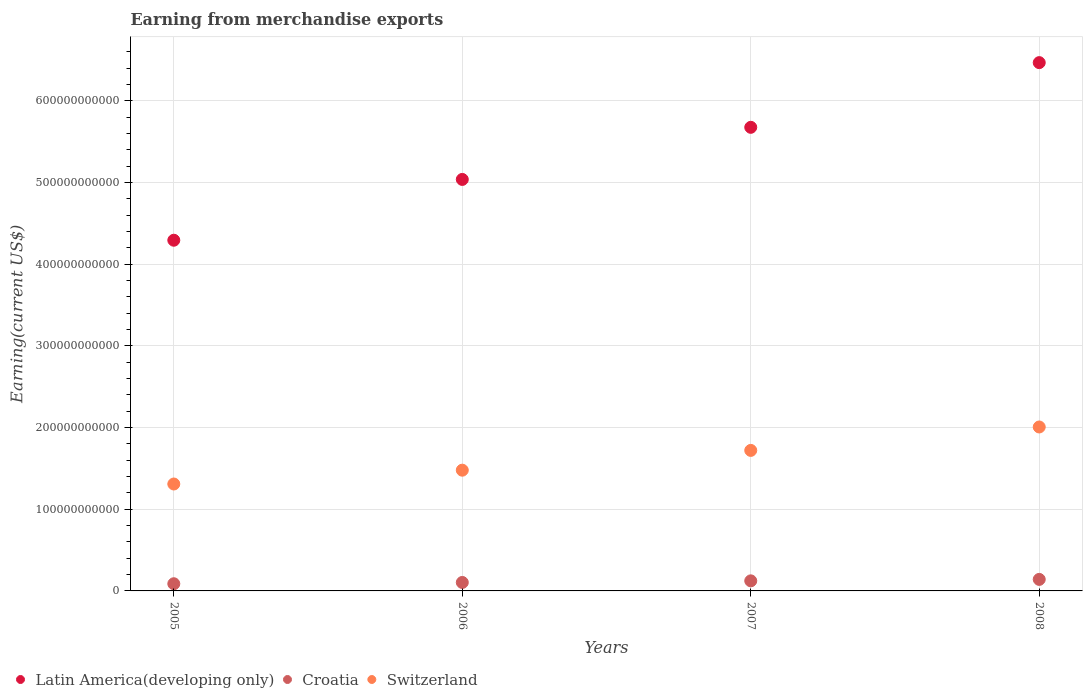How many different coloured dotlines are there?
Your answer should be compact. 3. Is the number of dotlines equal to the number of legend labels?
Ensure brevity in your answer.  Yes. What is the amount earned from merchandise exports in Latin America(developing only) in 2006?
Your answer should be very brief. 5.04e+11. Across all years, what is the maximum amount earned from merchandise exports in Switzerland?
Keep it short and to the point. 2.01e+11. Across all years, what is the minimum amount earned from merchandise exports in Switzerland?
Provide a succinct answer. 1.31e+11. In which year was the amount earned from merchandise exports in Latin America(developing only) maximum?
Offer a terse response. 2008. In which year was the amount earned from merchandise exports in Switzerland minimum?
Offer a very short reply. 2005. What is the total amount earned from merchandise exports in Switzerland in the graph?
Your response must be concise. 6.52e+11. What is the difference between the amount earned from merchandise exports in Switzerland in 2006 and that in 2008?
Your answer should be very brief. -5.29e+1. What is the difference between the amount earned from merchandise exports in Switzerland in 2005 and the amount earned from merchandise exports in Latin America(developing only) in 2008?
Keep it short and to the point. -5.16e+11. What is the average amount earned from merchandise exports in Switzerland per year?
Give a very brief answer. 1.63e+11. In the year 2007, what is the difference between the amount earned from merchandise exports in Croatia and amount earned from merchandise exports in Latin America(developing only)?
Make the answer very short. -5.55e+11. In how many years, is the amount earned from merchandise exports in Switzerland greater than 640000000000 US$?
Provide a succinct answer. 0. What is the ratio of the amount earned from merchandise exports in Croatia in 2007 to that in 2008?
Make the answer very short. 0.87. Is the difference between the amount earned from merchandise exports in Croatia in 2005 and 2007 greater than the difference between the amount earned from merchandise exports in Latin America(developing only) in 2005 and 2007?
Keep it short and to the point. Yes. What is the difference between the highest and the second highest amount earned from merchandise exports in Croatia?
Your answer should be compact. 1.77e+09. What is the difference between the highest and the lowest amount earned from merchandise exports in Croatia?
Your answer should be compact. 5.32e+09. In how many years, is the amount earned from merchandise exports in Latin America(developing only) greater than the average amount earned from merchandise exports in Latin America(developing only) taken over all years?
Offer a terse response. 2. Is the sum of the amount earned from merchandise exports in Switzerland in 2006 and 2007 greater than the maximum amount earned from merchandise exports in Latin America(developing only) across all years?
Make the answer very short. No. Is it the case that in every year, the sum of the amount earned from merchandise exports in Croatia and amount earned from merchandise exports in Switzerland  is greater than the amount earned from merchandise exports in Latin America(developing only)?
Your response must be concise. No. Does the amount earned from merchandise exports in Latin America(developing only) monotonically increase over the years?
Keep it short and to the point. Yes. Is the amount earned from merchandise exports in Latin America(developing only) strictly less than the amount earned from merchandise exports in Switzerland over the years?
Provide a short and direct response. No. How many years are there in the graph?
Offer a terse response. 4. What is the difference between two consecutive major ticks on the Y-axis?
Offer a very short reply. 1.00e+11. Does the graph contain any zero values?
Your answer should be compact. No. Where does the legend appear in the graph?
Keep it short and to the point. Bottom left. How many legend labels are there?
Keep it short and to the point. 3. What is the title of the graph?
Your response must be concise. Earning from merchandise exports. What is the label or title of the X-axis?
Give a very brief answer. Years. What is the label or title of the Y-axis?
Make the answer very short. Earning(current US$). What is the Earning(current US$) in Latin America(developing only) in 2005?
Ensure brevity in your answer.  4.29e+11. What is the Earning(current US$) of Croatia in 2005?
Give a very brief answer. 8.80e+09. What is the Earning(current US$) of Switzerland in 2005?
Your answer should be very brief. 1.31e+11. What is the Earning(current US$) of Latin America(developing only) in 2006?
Offer a very short reply. 5.04e+11. What is the Earning(current US$) in Croatia in 2006?
Provide a succinct answer. 1.04e+1. What is the Earning(current US$) of Switzerland in 2006?
Give a very brief answer. 1.48e+11. What is the Earning(current US$) in Latin America(developing only) in 2007?
Your answer should be compact. 5.68e+11. What is the Earning(current US$) of Croatia in 2007?
Give a very brief answer. 1.23e+1. What is the Earning(current US$) in Switzerland in 2007?
Give a very brief answer. 1.72e+11. What is the Earning(current US$) in Latin America(developing only) in 2008?
Keep it short and to the point. 6.47e+11. What is the Earning(current US$) in Croatia in 2008?
Offer a terse response. 1.41e+1. What is the Earning(current US$) in Switzerland in 2008?
Provide a succinct answer. 2.01e+11. Across all years, what is the maximum Earning(current US$) of Latin America(developing only)?
Your answer should be very brief. 6.47e+11. Across all years, what is the maximum Earning(current US$) in Croatia?
Ensure brevity in your answer.  1.41e+1. Across all years, what is the maximum Earning(current US$) in Switzerland?
Provide a short and direct response. 2.01e+11. Across all years, what is the minimum Earning(current US$) in Latin America(developing only)?
Make the answer very short. 4.29e+11. Across all years, what is the minimum Earning(current US$) of Croatia?
Your answer should be very brief. 8.80e+09. Across all years, what is the minimum Earning(current US$) of Switzerland?
Keep it short and to the point. 1.31e+11. What is the total Earning(current US$) of Latin America(developing only) in the graph?
Give a very brief answer. 2.15e+12. What is the total Earning(current US$) in Croatia in the graph?
Offer a terse response. 4.56e+1. What is the total Earning(current US$) of Switzerland in the graph?
Keep it short and to the point. 6.52e+11. What is the difference between the Earning(current US$) of Latin America(developing only) in 2005 and that in 2006?
Make the answer very short. -7.45e+1. What is the difference between the Earning(current US$) in Croatia in 2005 and that in 2006?
Make the answer very short. -1.57e+09. What is the difference between the Earning(current US$) of Switzerland in 2005 and that in 2006?
Your answer should be very brief. -1.69e+1. What is the difference between the Earning(current US$) of Latin America(developing only) in 2005 and that in 2007?
Make the answer very short. -1.38e+11. What is the difference between the Earning(current US$) in Croatia in 2005 and that in 2007?
Offer a terse response. -3.54e+09. What is the difference between the Earning(current US$) of Switzerland in 2005 and that in 2007?
Provide a short and direct response. -4.11e+1. What is the difference between the Earning(current US$) in Latin America(developing only) in 2005 and that in 2008?
Your answer should be very brief. -2.17e+11. What is the difference between the Earning(current US$) in Croatia in 2005 and that in 2008?
Provide a succinct answer. -5.32e+09. What is the difference between the Earning(current US$) in Switzerland in 2005 and that in 2008?
Your answer should be very brief. -6.98e+1. What is the difference between the Earning(current US$) in Latin America(developing only) in 2006 and that in 2007?
Your answer should be very brief. -6.38e+1. What is the difference between the Earning(current US$) in Croatia in 2006 and that in 2007?
Your response must be concise. -1.98e+09. What is the difference between the Earning(current US$) in Switzerland in 2006 and that in 2007?
Offer a terse response. -2.42e+1. What is the difference between the Earning(current US$) in Latin America(developing only) in 2006 and that in 2008?
Offer a very short reply. -1.43e+11. What is the difference between the Earning(current US$) of Croatia in 2006 and that in 2008?
Make the answer very short. -3.75e+09. What is the difference between the Earning(current US$) in Switzerland in 2006 and that in 2008?
Your answer should be compact. -5.29e+1. What is the difference between the Earning(current US$) in Latin America(developing only) in 2007 and that in 2008?
Provide a succinct answer. -7.92e+1. What is the difference between the Earning(current US$) of Croatia in 2007 and that in 2008?
Your answer should be very brief. -1.77e+09. What is the difference between the Earning(current US$) of Switzerland in 2007 and that in 2008?
Provide a short and direct response. -2.87e+1. What is the difference between the Earning(current US$) of Latin America(developing only) in 2005 and the Earning(current US$) of Croatia in 2006?
Your answer should be compact. 4.19e+11. What is the difference between the Earning(current US$) in Latin America(developing only) in 2005 and the Earning(current US$) in Switzerland in 2006?
Make the answer very short. 2.82e+11. What is the difference between the Earning(current US$) in Croatia in 2005 and the Earning(current US$) in Switzerland in 2006?
Make the answer very short. -1.39e+11. What is the difference between the Earning(current US$) of Latin America(developing only) in 2005 and the Earning(current US$) of Croatia in 2007?
Offer a very short reply. 4.17e+11. What is the difference between the Earning(current US$) of Latin America(developing only) in 2005 and the Earning(current US$) of Switzerland in 2007?
Your answer should be compact. 2.57e+11. What is the difference between the Earning(current US$) in Croatia in 2005 and the Earning(current US$) in Switzerland in 2007?
Your answer should be very brief. -1.63e+11. What is the difference between the Earning(current US$) of Latin America(developing only) in 2005 and the Earning(current US$) of Croatia in 2008?
Your answer should be very brief. 4.15e+11. What is the difference between the Earning(current US$) of Latin America(developing only) in 2005 and the Earning(current US$) of Switzerland in 2008?
Your answer should be compact. 2.29e+11. What is the difference between the Earning(current US$) in Croatia in 2005 and the Earning(current US$) in Switzerland in 2008?
Make the answer very short. -1.92e+11. What is the difference between the Earning(current US$) of Latin America(developing only) in 2006 and the Earning(current US$) of Croatia in 2007?
Ensure brevity in your answer.  4.92e+11. What is the difference between the Earning(current US$) of Latin America(developing only) in 2006 and the Earning(current US$) of Switzerland in 2007?
Offer a very short reply. 3.32e+11. What is the difference between the Earning(current US$) in Croatia in 2006 and the Earning(current US$) in Switzerland in 2007?
Give a very brief answer. -1.62e+11. What is the difference between the Earning(current US$) in Latin America(developing only) in 2006 and the Earning(current US$) in Croatia in 2008?
Ensure brevity in your answer.  4.90e+11. What is the difference between the Earning(current US$) in Latin America(developing only) in 2006 and the Earning(current US$) in Switzerland in 2008?
Make the answer very short. 3.03e+11. What is the difference between the Earning(current US$) of Croatia in 2006 and the Earning(current US$) of Switzerland in 2008?
Your answer should be very brief. -1.90e+11. What is the difference between the Earning(current US$) of Latin America(developing only) in 2007 and the Earning(current US$) of Croatia in 2008?
Give a very brief answer. 5.54e+11. What is the difference between the Earning(current US$) of Latin America(developing only) in 2007 and the Earning(current US$) of Switzerland in 2008?
Offer a terse response. 3.67e+11. What is the difference between the Earning(current US$) in Croatia in 2007 and the Earning(current US$) in Switzerland in 2008?
Offer a terse response. -1.88e+11. What is the average Earning(current US$) of Latin America(developing only) per year?
Your response must be concise. 5.37e+11. What is the average Earning(current US$) in Croatia per year?
Your answer should be very brief. 1.14e+1. What is the average Earning(current US$) of Switzerland per year?
Ensure brevity in your answer.  1.63e+11. In the year 2005, what is the difference between the Earning(current US$) in Latin America(developing only) and Earning(current US$) in Croatia?
Give a very brief answer. 4.21e+11. In the year 2005, what is the difference between the Earning(current US$) of Latin America(developing only) and Earning(current US$) of Switzerland?
Give a very brief answer. 2.99e+11. In the year 2005, what is the difference between the Earning(current US$) in Croatia and Earning(current US$) in Switzerland?
Provide a succinct answer. -1.22e+11. In the year 2006, what is the difference between the Earning(current US$) of Latin America(developing only) and Earning(current US$) of Croatia?
Ensure brevity in your answer.  4.94e+11. In the year 2006, what is the difference between the Earning(current US$) of Latin America(developing only) and Earning(current US$) of Switzerland?
Ensure brevity in your answer.  3.56e+11. In the year 2006, what is the difference between the Earning(current US$) of Croatia and Earning(current US$) of Switzerland?
Provide a short and direct response. -1.37e+11. In the year 2007, what is the difference between the Earning(current US$) of Latin America(developing only) and Earning(current US$) of Croatia?
Provide a succinct answer. 5.55e+11. In the year 2007, what is the difference between the Earning(current US$) of Latin America(developing only) and Earning(current US$) of Switzerland?
Provide a succinct answer. 3.96e+11. In the year 2007, what is the difference between the Earning(current US$) of Croatia and Earning(current US$) of Switzerland?
Provide a short and direct response. -1.60e+11. In the year 2008, what is the difference between the Earning(current US$) of Latin America(developing only) and Earning(current US$) of Croatia?
Keep it short and to the point. 6.33e+11. In the year 2008, what is the difference between the Earning(current US$) of Latin America(developing only) and Earning(current US$) of Switzerland?
Provide a short and direct response. 4.46e+11. In the year 2008, what is the difference between the Earning(current US$) in Croatia and Earning(current US$) in Switzerland?
Your answer should be very brief. -1.87e+11. What is the ratio of the Earning(current US$) of Latin America(developing only) in 2005 to that in 2006?
Your answer should be compact. 0.85. What is the ratio of the Earning(current US$) of Croatia in 2005 to that in 2006?
Offer a terse response. 0.85. What is the ratio of the Earning(current US$) in Switzerland in 2005 to that in 2006?
Make the answer very short. 0.89. What is the ratio of the Earning(current US$) in Latin America(developing only) in 2005 to that in 2007?
Provide a succinct answer. 0.76. What is the ratio of the Earning(current US$) of Croatia in 2005 to that in 2007?
Your answer should be very brief. 0.71. What is the ratio of the Earning(current US$) of Switzerland in 2005 to that in 2007?
Your answer should be compact. 0.76. What is the ratio of the Earning(current US$) in Latin America(developing only) in 2005 to that in 2008?
Offer a terse response. 0.66. What is the ratio of the Earning(current US$) of Croatia in 2005 to that in 2008?
Your response must be concise. 0.62. What is the ratio of the Earning(current US$) of Switzerland in 2005 to that in 2008?
Offer a very short reply. 0.65. What is the ratio of the Earning(current US$) in Latin America(developing only) in 2006 to that in 2007?
Keep it short and to the point. 0.89. What is the ratio of the Earning(current US$) in Croatia in 2006 to that in 2007?
Provide a short and direct response. 0.84. What is the ratio of the Earning(current US$) in Switzerland in 2006 to that in 2007?
Give a very brief answer. 0.86. What is the ratio of the Earning(current US$) of Latin America(developing only) in 2006 to that in 2008?
Keep it short and to the point. 0.78. What is the ratio of the Earning(current US$) in Croatia in 2006 to that in 2008?
Make the answer very short. 0.73. What is the ratio of the Earning(current US$) of Switzerland in 2006 to that in 2008?
Offer a very short reply. 0.74. What is the ratio of the Earning(current US$) of Latin America(developing only) in 2007 to that in 2008?
Offer a terse response. 0.88. What is the ratio of the Earning(current US$) of Croatia in 2007 to that in 2008?
Your answer should be very brief. 0.87. What is the ratio of the Earning(current US$) of Switzerland in 2007 to that in 2008?
Give a very brief answer. 0.86. What is the difference between the highest and the second highest Earning(current US$) in Latin America(developing only)?
Your answer should be very brief. 7.92e+1. What is the difference between the highest and the second highest Earning(current US$) of Croatia?
Give a very brief answer. 1.77e+09. What is the difference between the highest and the second highest Earning(current US$) in Switzerland?
Give a very brief answer. 2.87e+1. What is the difference between the highest and the lowest Earning(current US$) of Latin America(developing only)?
Offer a very short reply. 2.17e+11. What is the difference between the highest and the lowest Earning(current US$) of Croatia?
Your answer should be very brief. 5.32e+09. What is the difference between the highest and the lowest Earning(current US$) in Switzerland?
Give a very brief answer. 6.98e+1. 